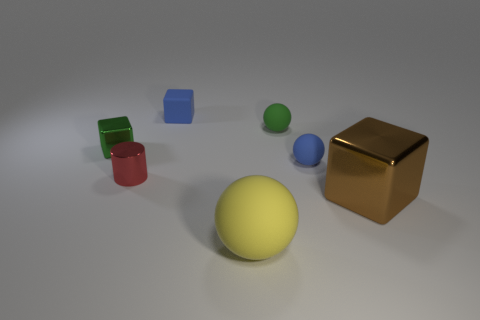Add 1 blue matte cubes. How many objects exist? 8 Subtract 1 brown blocks. How many objects are left? 6 Subtract all spheres. How many objects are left? 4 Subtract all green matte things. Subtract all big matte balls. How many objects are left? 5 Add 7 green matte things. How many green matte things are left? 8 Add 3 tiny rubber objects. How many tiny rubber objects exist? 6 